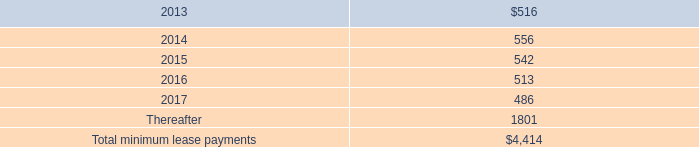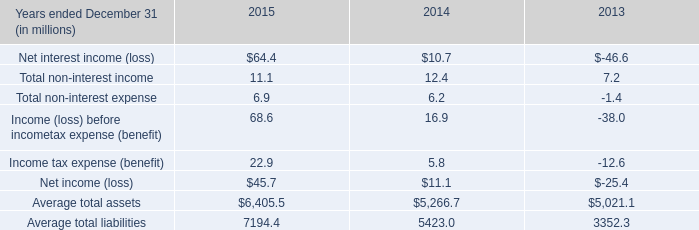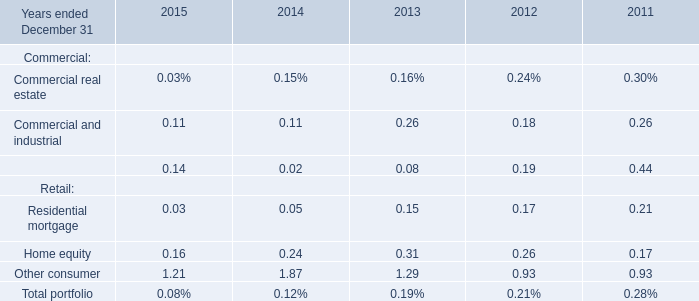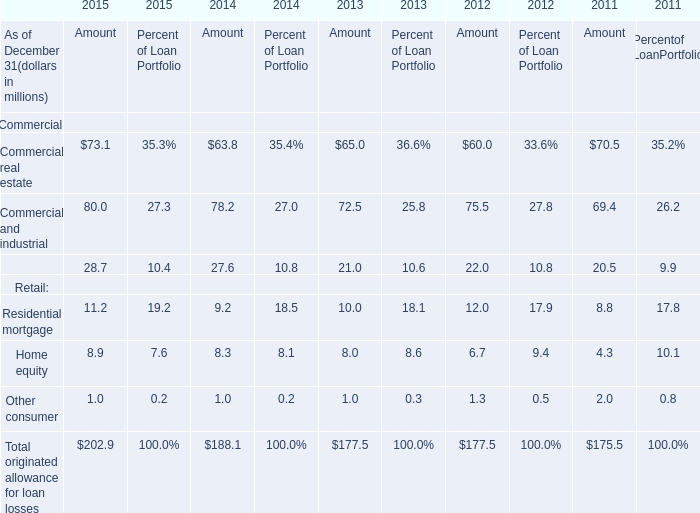If Commercial real estate develops with the same increasing rate in 2015, what will it reach in 2016? (in million) 
Computations: (73.1 * (1 + ((73.1 - 63.8) / 63.8)))
Answer: 83.75564. 